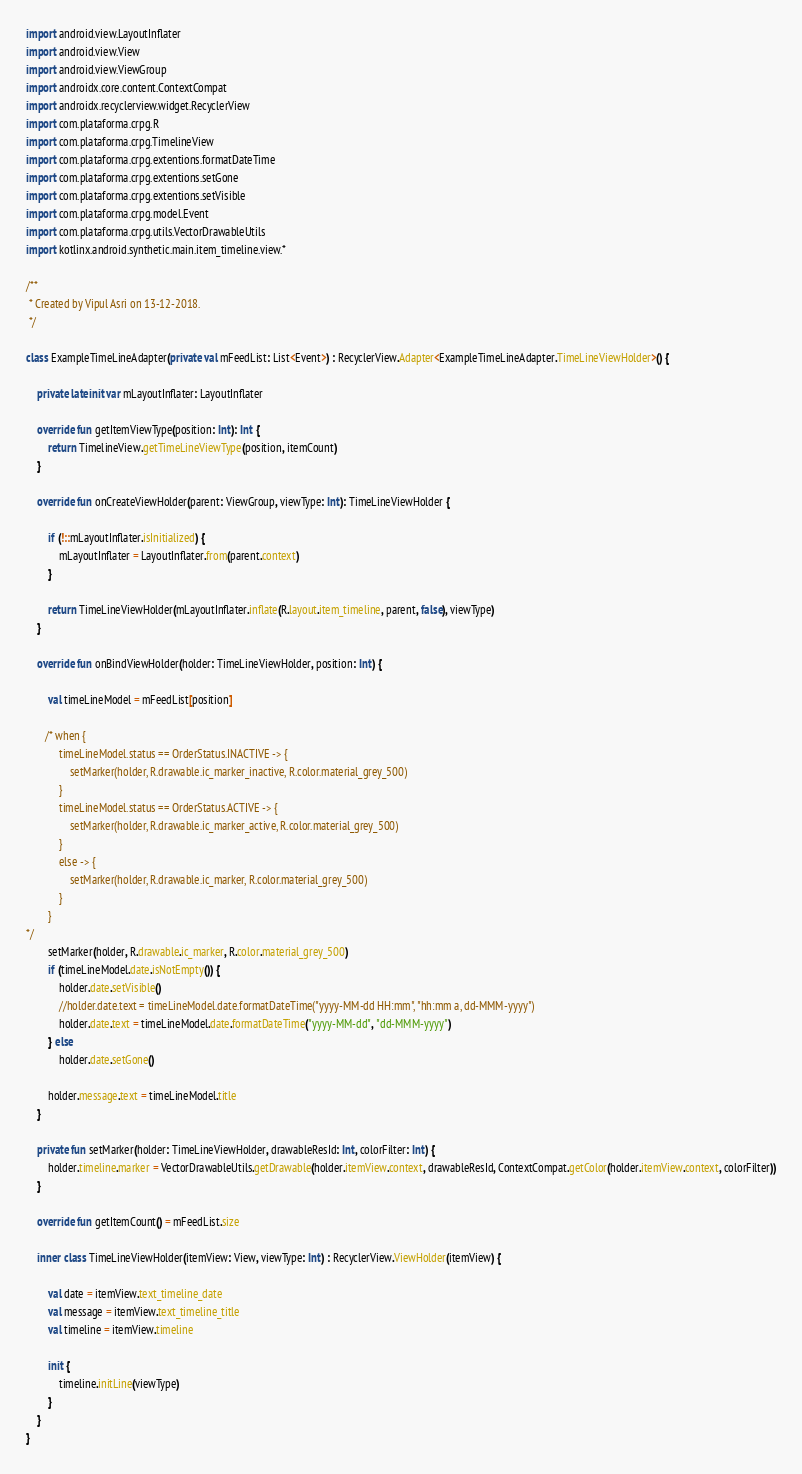Convert code to text. <code><loc_0><loc_0><loc_500><loc_500><_Kotlin_>
import android.view.LayoutInflater
import android.view.View
import android.view.ViewGroup
import androidx.core.content.ContextCompat
import androidx.recyclerview.widget.RecyclerView
import com.plataforma.crpg.R
import com.plataforma.crpg.TimelineView
import com.plataforma.crpg.extentions.formatDateTime
import com.plataforma.crpg.extentions.setGone
import com.plataforma.crpg.extentions.setVisible
import com.plataforma.crpg.model.Event
import com.plataforma.crpg.utils.VectorDrawableUtils
import kotlinx.android.synthetic.main.item_timeline.view.*

/**
 * Created by Vipul Asri on 13-12-2018.
 */

class ExampleTimeLineAdapter(private val mFeedList: List<Event>) : RecyclerView.Adapter<ExampleTimeLineAdapter.TimeLineViewHolder>() {

    private lateinit var mLayoutInflater: LayoutInflater

    override fun getItemViewType(position: Int): Int {
        return TimelineView.getTimeLineViewType(position, itemCount)
    }

    override fun onCreateViewHolder(parent: ViewGroup, viewType: Int): TimeLineViewHolder {

        if (!::mLayoutInflater.isInitialized) {
            mLayoutInflater = LayoutInflater.from(parent.context)
        }

        return TimeLineViewHolder(mLayoutInflater.inflate(R.layout.item_timeline, parent, false), viewType)
    }

    override fun onBindViewHolder(holder: TimeLineViewHolder, position: Int) {

        val timeLineModel = mFeedList[position]

       /* when {
            timeLineModel.status == OrderStatus.INACTIVE -> {
                setMarker(holder, R.drawable.ic_marker_inactive, R.color.material_grey_500)
            }
            timeLineModel.status == OrderStatus.ACTIVE -> {
                setMarker(holder, R.drawable.ic_marker_active, R.color.material_grey_500)
            }
            else -> {
                setMarker(holder, R.drawable.ic_marker, R.color.material_grey_500)
            }
        }
*/
        setMarker(holder, R.drawable.ic_marker, R.color.material_grey_500)
        if (timeLineModel.date.isNotEmpty()) {
            holder.date.setVisible()
            //holder.date.text = timeLineModel.date.formatDateTime("yyyy-MM-dd HH:mm", "hh:mm a, dd-MMM-yyyy")
            holder.date.text = timeLineModel.date.formatDateTime("yyyy-MM-dd", "dd-MMM-yyyy")
        } else
            holder.date.setGone()

        holder.message.text = timeLineModel.title
    }

    private fun setMarker(holder: TimeLineViewHolder, drawableResId: Int, colorFilter: Int) {
        holder.timeline.marker = VectorDrawableUtils.getDrawable(holder.itemView.context, drawableResId, ContextCompat.getColor(holder.itemView.context, colorFilter))
    }

    override fun getItemCount() = mFeedList.size

    inner class TimeLineViewHolder(itemView: View, viewType: Int) : RecyclerView.ViewHolder(itemView) {

        val date = itemView.text_timeline_date
        val message = itemView.text_timeline_title
        val timeline = itemView.timeline

        init {
            timeline.initLine(viewType)
        }
    }
}
</code> 